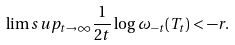Convert formula to latex. <formula><loc_0><loc_0><loc_500><loc_500>\lim s u p _ { t \rightarrow \infty } \frac { 1 } { 2 t } \log \omega _ { - t } ( T _ { t } ) < - r .</formula> 